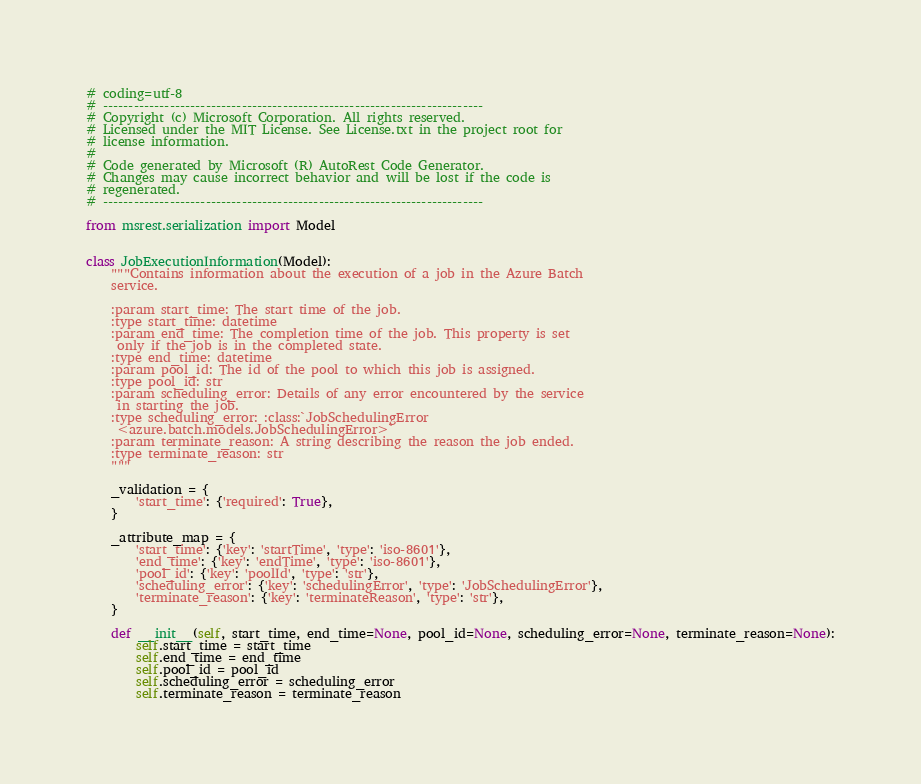<code> <loc_0><loc_0><loc_500><loc_500><_Python_># coding=utf-8
# --------------------------------------------------------------------------
# Copyright (c) Microsoft Corporation. All rights reserved.
# Licensed under the MIT License. See License.txt in the project root for
# license information.
#
# Code generated by Microsoft (R) AutoRest Code Generator.
# Changes may cause incorrect behavior and will be lost if the code is
# regenerated.
# --------------------------------------------------------------------------

from msrest.serialization import Model


class JobExecutionInformation(Model):
    """Contains information about the execution of a job in the Azure Batch
    service.

    :param start_time: The start time of the job.
    :type start_time: datetime
    :param end_time: The completion time of the job. This property is set
     only if the job is in the completed state.
    :type end_time: datetime
    :param pool_id: The id of the pool to which this job is assigned.
    :type pool_id: str
    :param scheduling_error: Details of any error encountered by the service
     in starting the job.
    :type scheduling_error: :class:`JobSchedulingError
     <azure.batch.models.JobSchedulingError>`
    :param terminate_reason: A string describing the reason the job ended.
    :type terminate_reason: str
    """ 

    _validation = {
        'start_time': {'required': True},
    }

    _attribute_map = {
        'start_time': {'key': 'startTime', 'type': 'iso-8601'},
        'end_time': {'key': 'endTime', 'type': 'iso-8601'},
        'pool_id': {'key': 'poolId', 'type': 'str'},
        'scheduling_error': {'key': 'schedulingError', 'type': 'JobSchedulingError'},
        'terminate_reason': {'key': 'terminateReason', 'type': 'str'},
    }

    def __init__(self, start_time, end_time=None, pool_id=None, scheduling_error=None, terminate_reason=None):
        self.start_time = start_time
        self.end_time = end_time
        self.pool_id = pool_id
        self.scheduling_error = scheduling_error
        self.terminate_reason = terminate_reason
</code> 